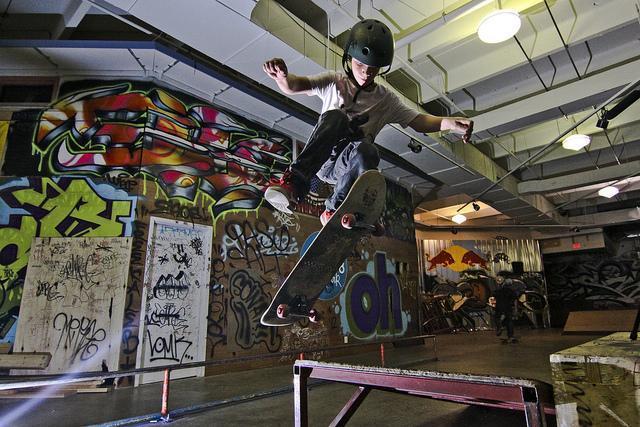How many feet does the male have touching the skateboard?
Give a very brief answer. 1. 